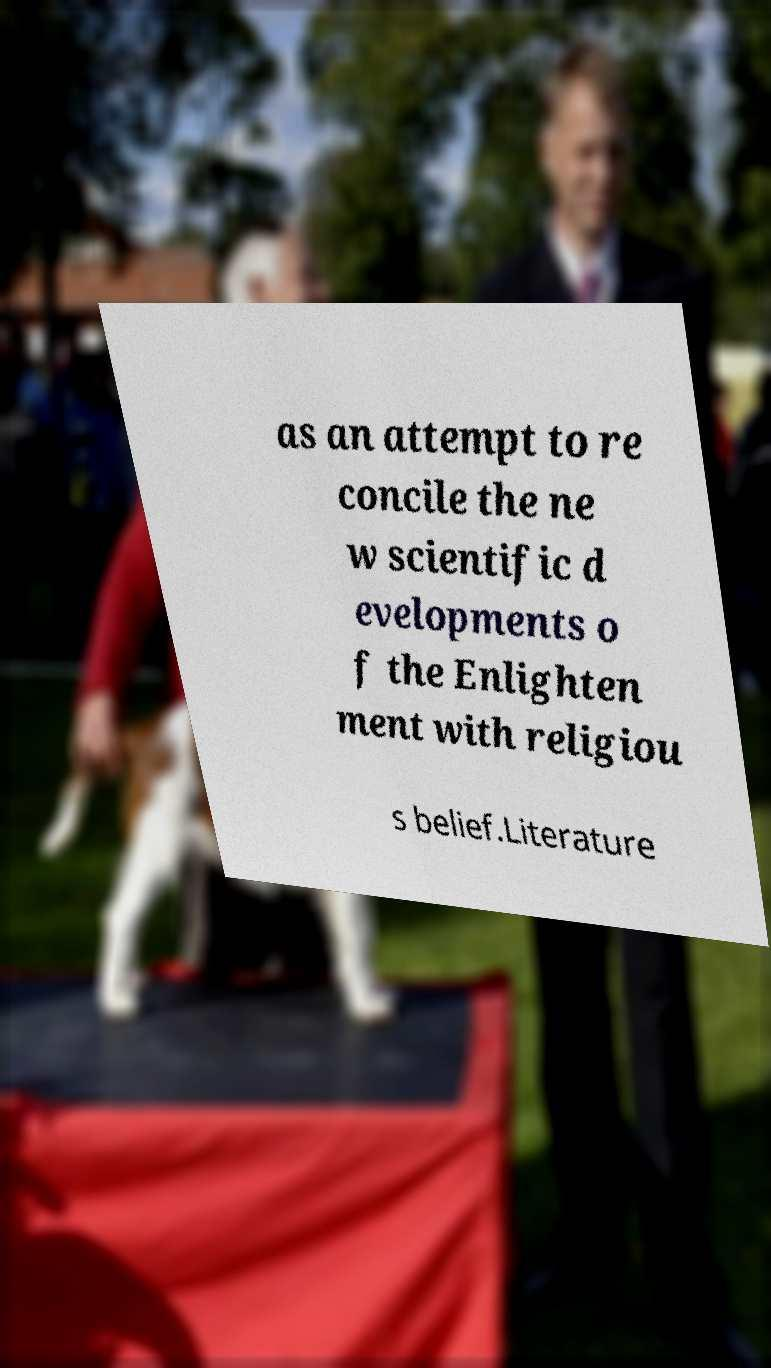Could you extract and type out the text from this image? as an attempt to re concile the ne w scientific d evelopments o f the Enlighten ment with religiou s belief.Literature 